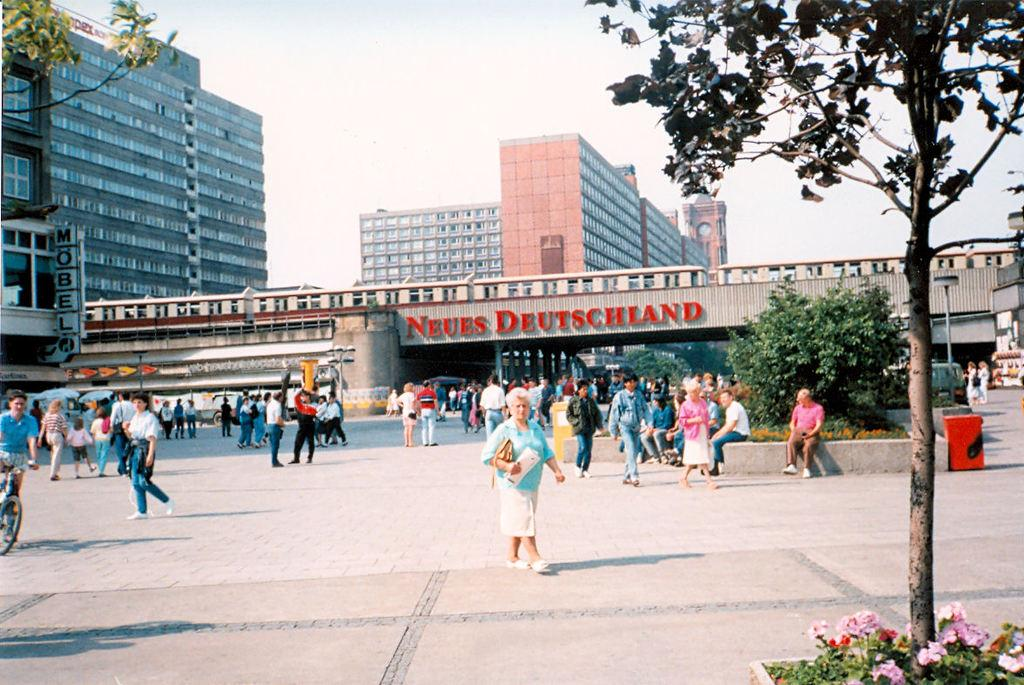How many people can be seen in the image? There are people in the image, but the exact number cannot be determined from the provided facts. What type of structure is present in the image? There is a bridge in the image. What can be found on the walls in the image? There are posters in the image. What type of buildings are visible in the image? There are buildings with windows in the image. What type of vegetation is present in the image? There are trees, plants, and flowers in the image. What type of transportation is visible in the image? There are vehicles in the image. What part of the natural environment is visible in the image? The sky is visible in the image. What objects can be seen on the road in the image? There are objects on the road in the image, but their specific nature cannot be determined from the provided facts. What type of record is being played in the image? There is no record player or record visible in the image. What type of sign is present in the image? There is no sign visible in the image. 